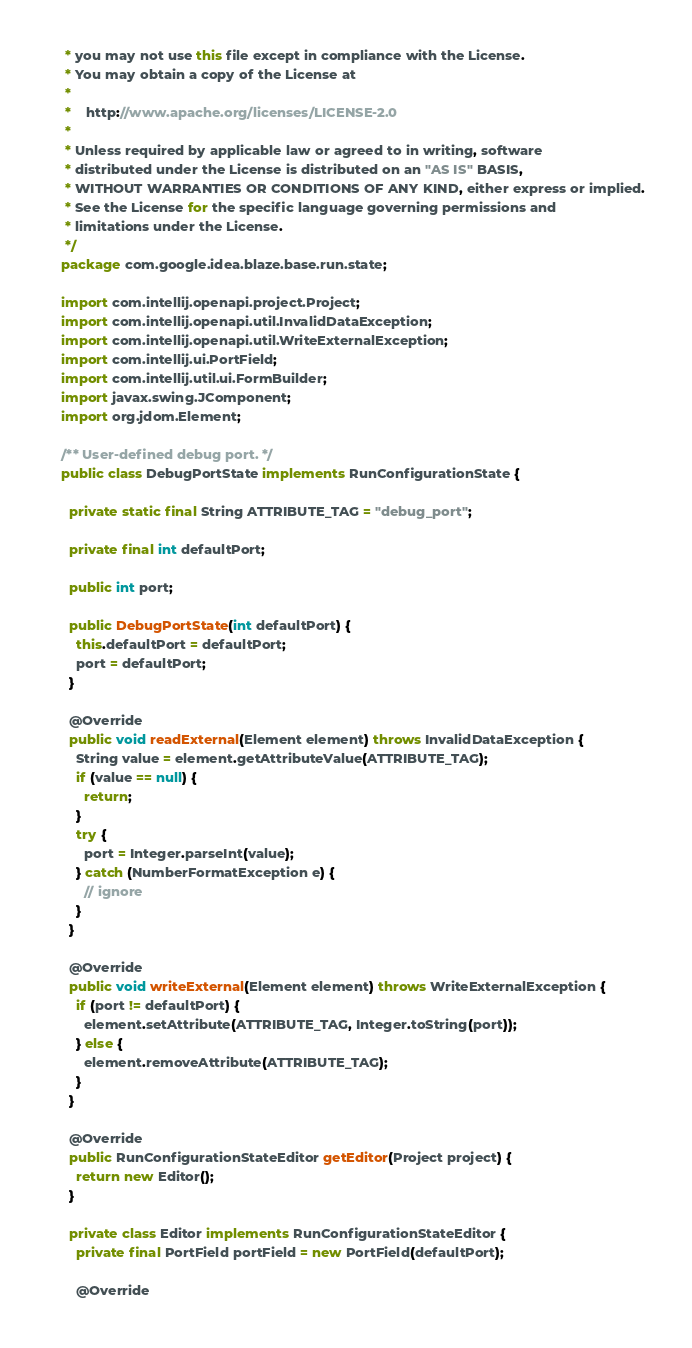<code> <loc_0><loc_0><loc_500><loc_500><_Java_> * you may not use this file except in compliance with the License.
 * You may obtain a copy of the License at
 *
 *    http://www.apache.org/licenses/LICENSE-2.0
 *
 * Unless required by applicable law or agreed to in writing, software
 * distributed under the License is distributed on an "AS IS" BASIS,
 * WITHOUT WARRANTIES OR CONDITIONS OF ANY KIND, either express or implied.
 * See the License for the specific language governing permissions and
 * limitations under the License.
 */
package com.google.idea.blaze.base.run.state;

import com.intellij.openapi.project.Project;
import com.intellij.openapi.util.InvalidDataException;
import com.intellij.openapi.util.WriteExternalException;
import com.intellij.ui.PortField;
import com.intellij.util.ui.FormBuilder;
import javax.swing.JComponent;
import org.jdom.Element;

/** User-defined debug port. */
public class DebugPortState implements RunConfigurationState {

  private static final String ATTRIBUTE_TAG = "debug_port";

  private final int defaultPort;

  public int port;

  public DebugPortState(int defaultPort) {
    this.defaultPort = defaultPort;
    port = defaultPort;
  }

  @Override
  public void readExternal(Element element) throws InvalidDataException {
    String value = element.getAttributeValue(ATTRIBUTE_TAG);
    if (value == null) {
      return;
    }
    try {
      port = Integer.parseInt(value);
    } catch (NumberFormatException e) {
      // ignore
    }
  }

  @Override
  public void writeExternal(Element element) throws WriteExternalException {
    if (port != defaultPort) {
      element.setAttribute(ATTRIBUTE_TAG, Integer.toString(port));
    } else {
      element.removeAttribute(ATTRIBUTE_TAG);
    }
  }

  @Override
  public RunConfigurationStateEditor getEditor(Project project) {
    return new Editor();
  }

  private class Editor implements RunConfigurationStateEditor {
    private final PortField portField = new PortField(defaultPort);

    @Override</code> 